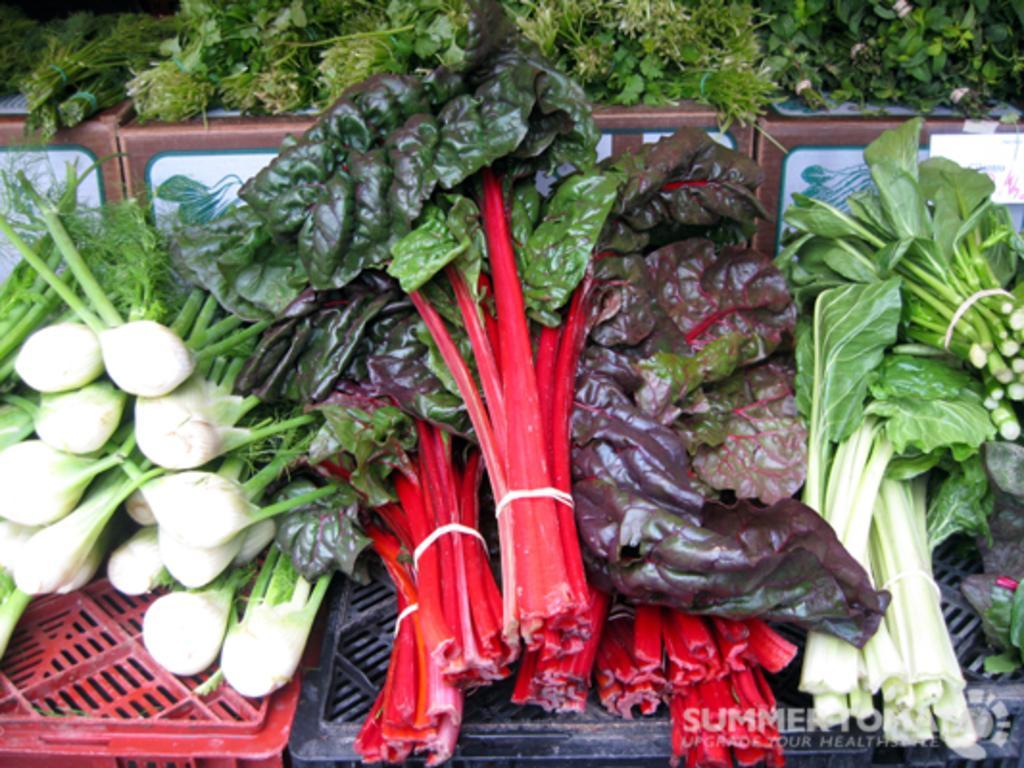In one or two sentences, can you explain what this image depicts? In the picture I can see few green leafy vegetables placed on an object. 